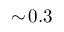<formula> <loc_0><loc_0><loc_500><loc_500>\sim \, 0 . 3</formula> 